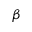<formula> <loc_0><loc_0><loc_500><loc_500>\beta</formula> 